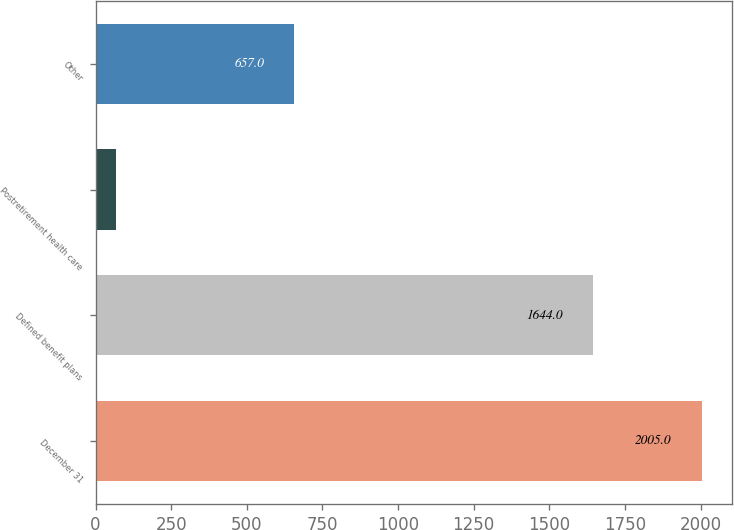Convert chart. <chart><loc_0><loc_0><loc_500><loc_500><bar_chart><fcel>December 31<fcel>Defined benefit plans<fcel>Postretirement health care<fcel>Other<nl><fcel>2005<fcel>1644<fcel>66<fcel>657<nl></chart> 